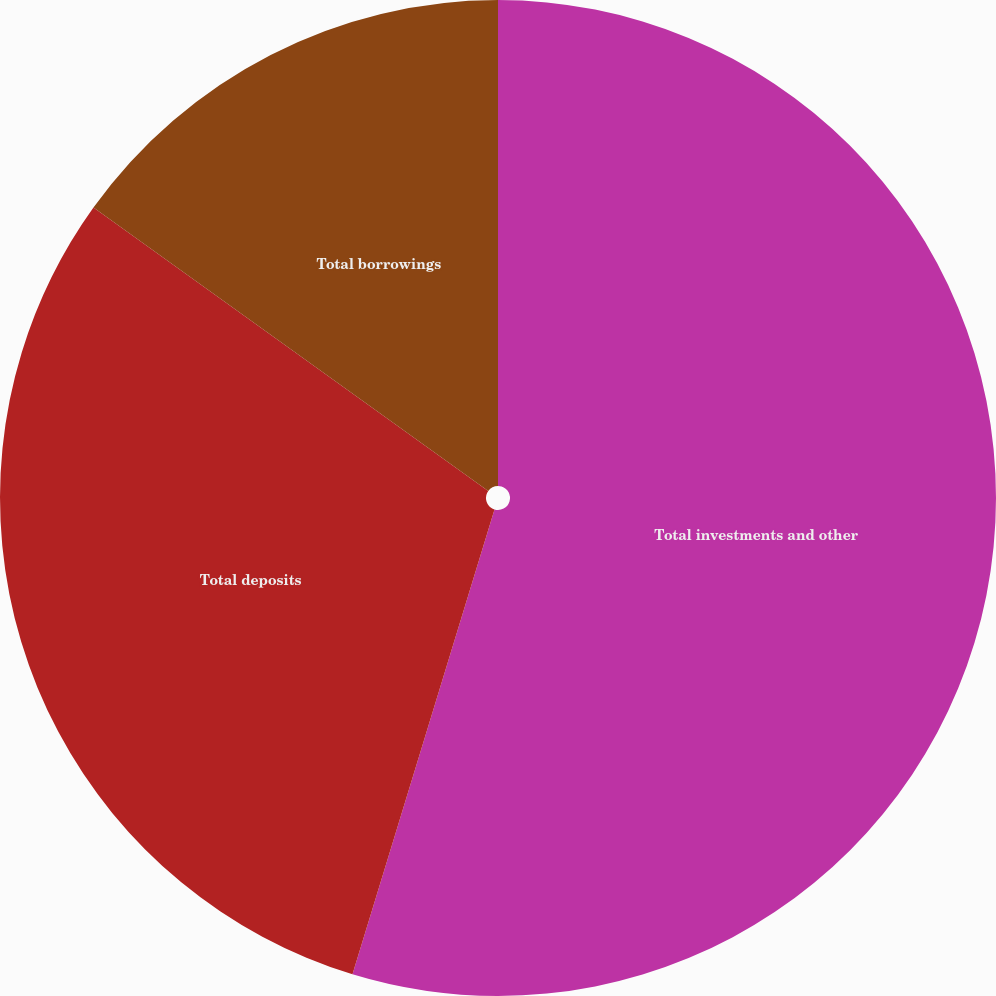Convert chart. <chart><loc_0><loc_0><loc_500><loc_500><pie_chart><fcel>Total investments and other<fcel>Total deposits<fcel>Total borrowings<nl><fcel>54.72%<fcel>30.19%<fcel>15.09%<nl></chart> 